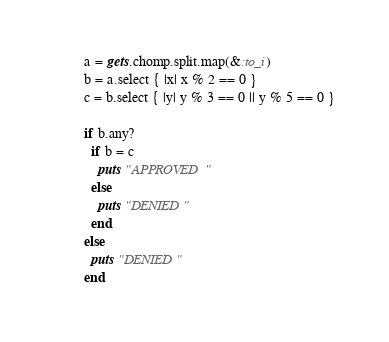<code> <loc_0><loc_0><loc_500><loc_500><_Ruby_>a = gets.chomp.split.map(&:to_i)
b = a.select { |x| x % 2 == 0 }
c = b.select { |y| y % 3 == 0 || y % 5 == 0 }

if b.any?
  if b = c
  	puts "APPROVED"
  else
    puts "DENIED"
  end
else
  puts "DENIED"
end
</code> 